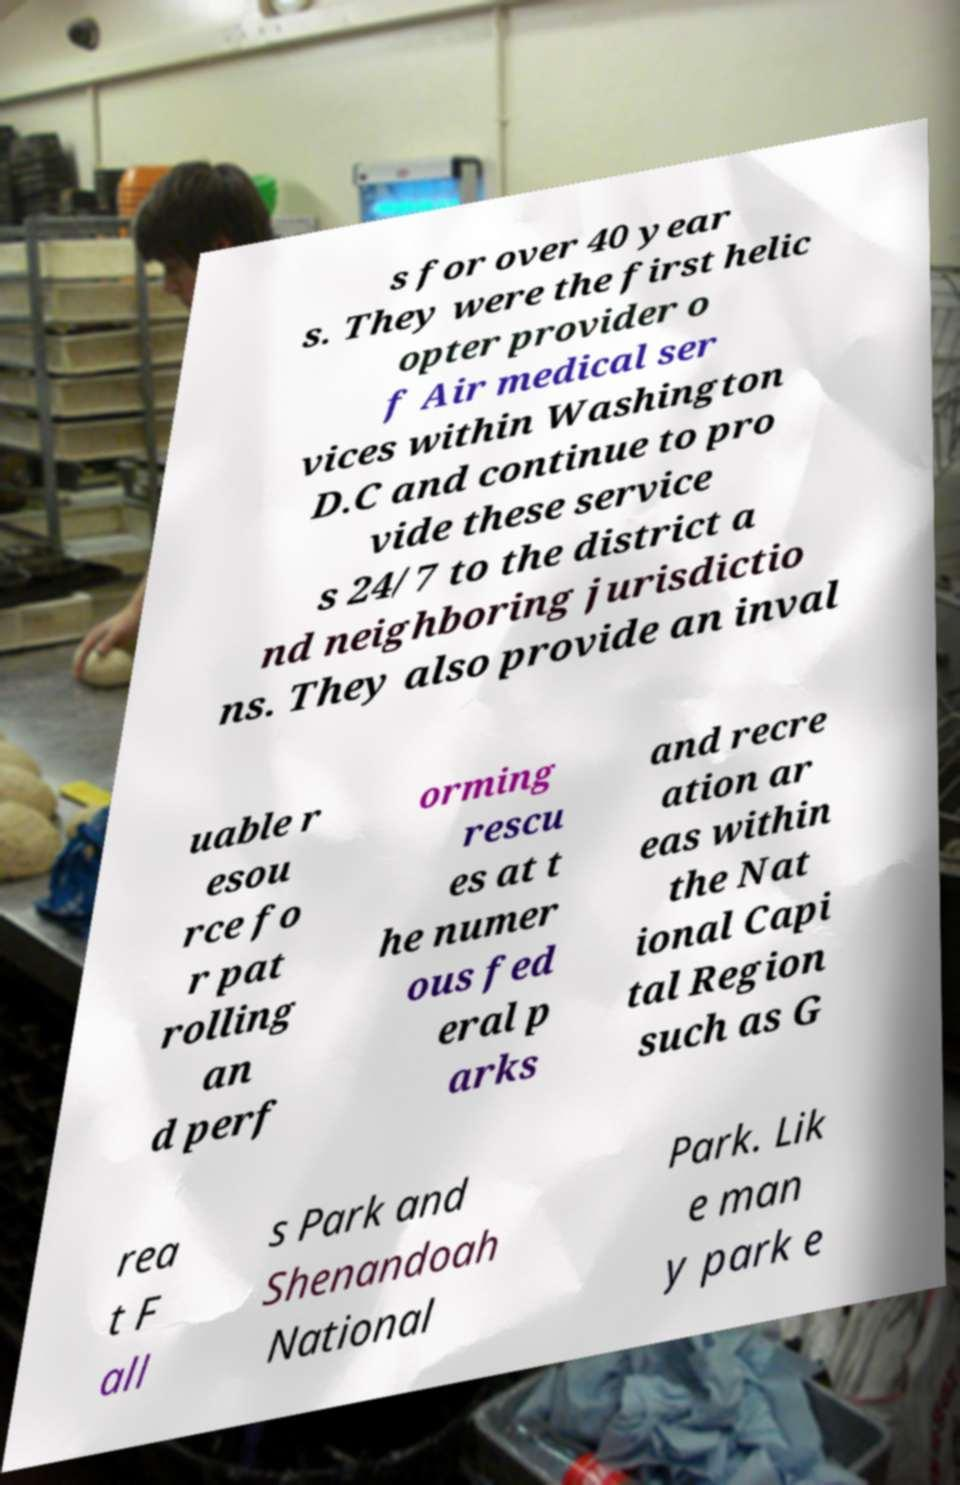I need the written content from this picture converted into text. Can you do that? s for over 40 year s. They were the first helic opter provider o f Air medical ser vices within Washington D.C and continue to pro vide these service s 24/7 to the district a nd neighboring jurisdictio ns. They also provide an inval uable r esou rce fo r pat rolling an d perf orming rescu es at t he numer ous fed eral p arks and recre ation ar eas within the Nat ional Capi tal Region such as G rea t F all s Park and Shenandoah National Park. Lik e man y park e 